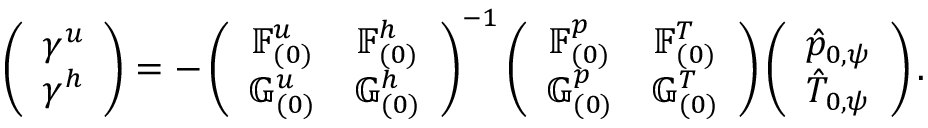<formula> <loc_0><loc_0><loc_500><loc_500>\left ( \begin{array} { c } { \gamma ^ { u } } \\ { \gamma ^ { h } } \end{array} \right ) = - \left ( \begin{array} { c c } { \mathbb { F } _ { ( 0 ) } ^ { u } } & { \mathbb { F } _ { ( 0 ) } ^ { h } } \\ { \mathbb { G } _ { ( 0 ) } ^ { u } } & { \mathbb { G } _ { ( 0 ) } ^ { h } } \end{array} \right ) ^ { - 1 } \left ( \begin{array} { c c } { \mathbb { F } _ { ( 0 ) } ^ { p } } & { \mathbb { F } _ { ( 0 ) } ^ { T } } \\ { \mathbb { G } _ { ( 0 ) } ^ { p } } & { \mathbb { G } _ { ( 0 ) } ^ { T } } \end{array} \right ) \left ( \begin{array} { c } { \hat { p } _ { 0 , \psi } } \\ { \hat { T } _ { 0 , \psi } } \end{array} \right ) .</formula> 